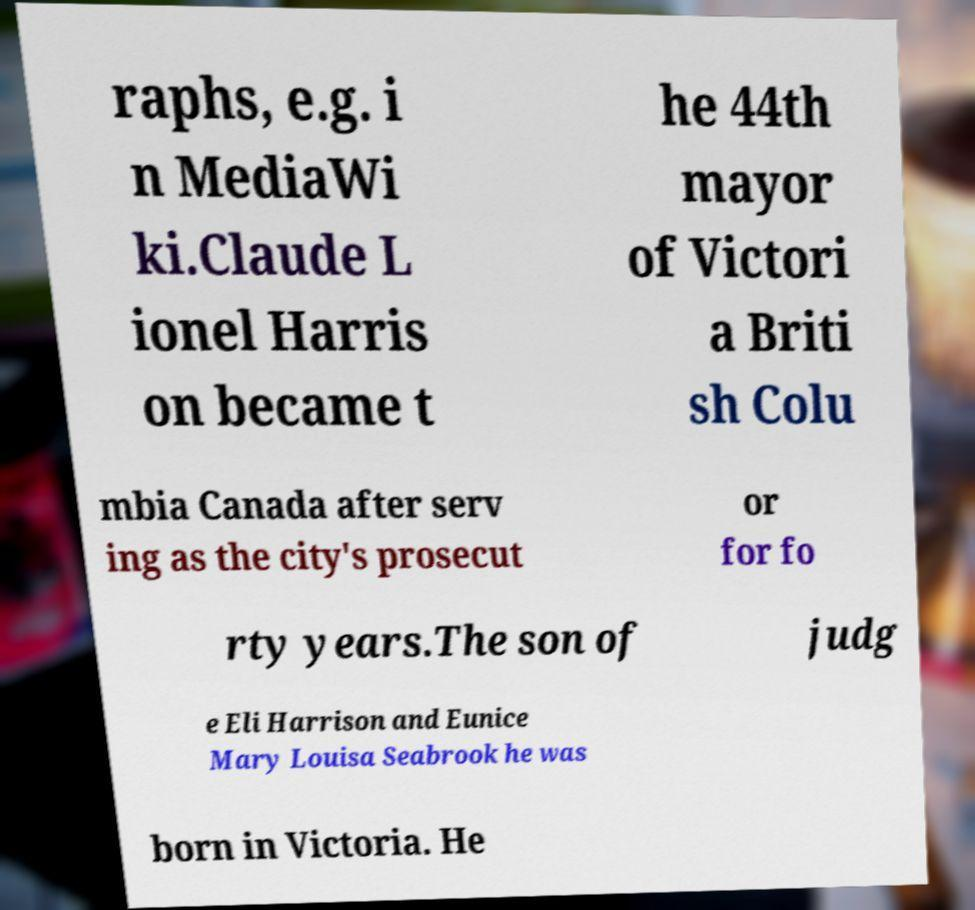Can you accurately transcribe the text from the provided image for me? raphs, e.g. i n MediaWi ki.Claude L ionel Harris on became t he 44th mayor of Victori a Briti sh Colu mbia Canada after serv ing as the city's prosecut or for fo rty years.The son of judg e Eli Harrison and Eunice Mary Louisa Seabrook he was born in Victoria. He 